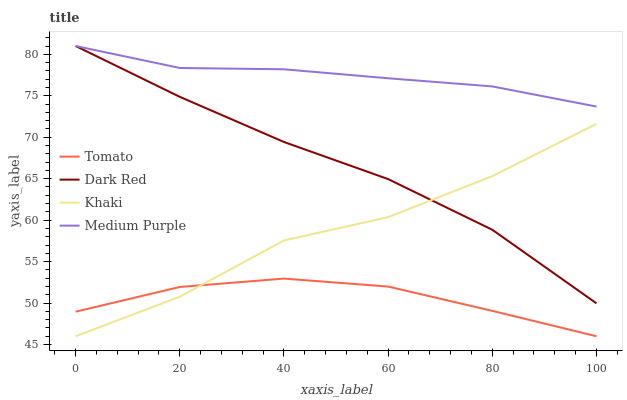Does Tomato have the minimum area under the curve?
Answer yes or no. Yes. Does Medium Purple have the maximum area under the curve?
Answer yes or no. Yes. Does Dark Red have the minimum area under the curve?
Answer yes or no. No. Does Dark Red have the maximum area under the curve?
Answer yes or no. No. Is Medium Purple the smoothest?
Answer yes or no. Yes. Is Khaki the roughest?
Answer yes or no. Yes. Is Dark Red the smoothest?
Answer yes or no. No. Is Dark Red the roughest?
Answer yes or no. No. Does Dark Red have the lowest value?
Answer yes or no. No. Does Medium Purple have the highest value?
Answer yes or no. Yes. Does Khaki have the highest value?
Answer yes or no. No. Is Khaki less than Medium Purple?
Answer yes or no. Yes. Is Medium Purple greater than Khaki?
Answer yes or no. Yes. Does Dark Red intersect Medium Purple?
Answer yes or no. Yes. Is Dark Red less than Medium Purple?
Answer yes or no. No. Is Dark Red greater than Medium Purple?
Answer yes or no. No. Does Khaki intersect Medium Purple?
Answer yes or no. No. 